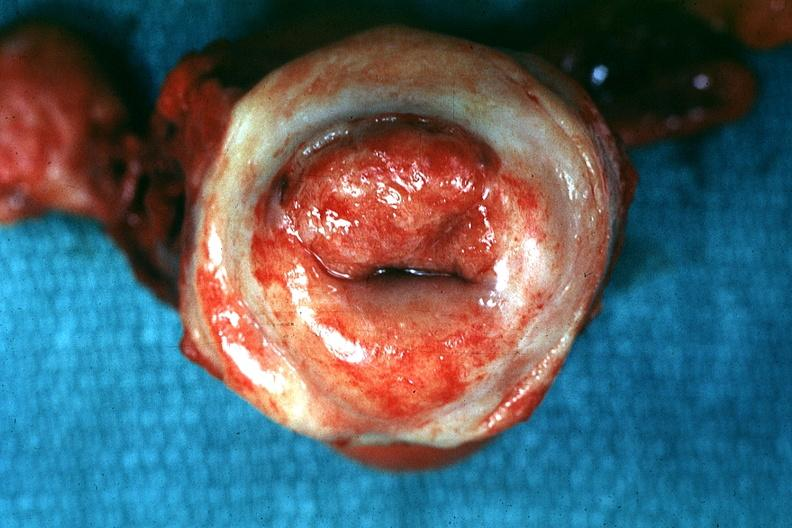s uterus present?
Answer the question using a single word or phrase. Yes 